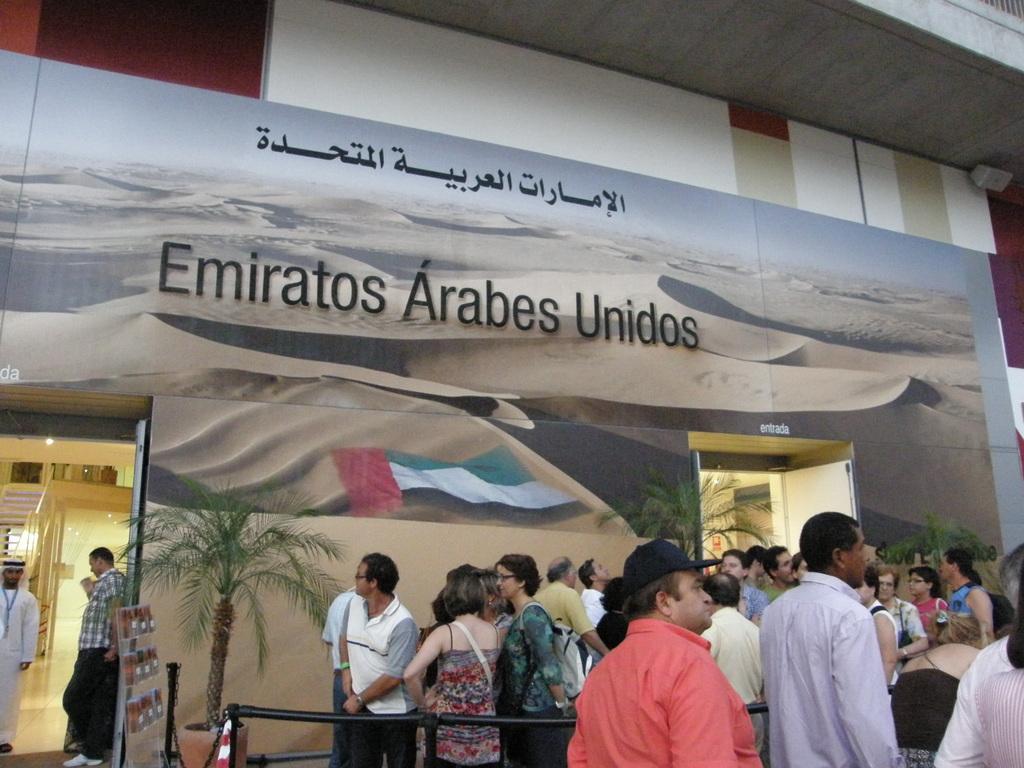Can you describe this image briefly? In the center of the image a border, plants are present. At the bottom of the image a group of people are standing. On the left side of the image we can see the stairs, floor are present. At the bottom of the image rod is there. At the top of the image roof is present. 